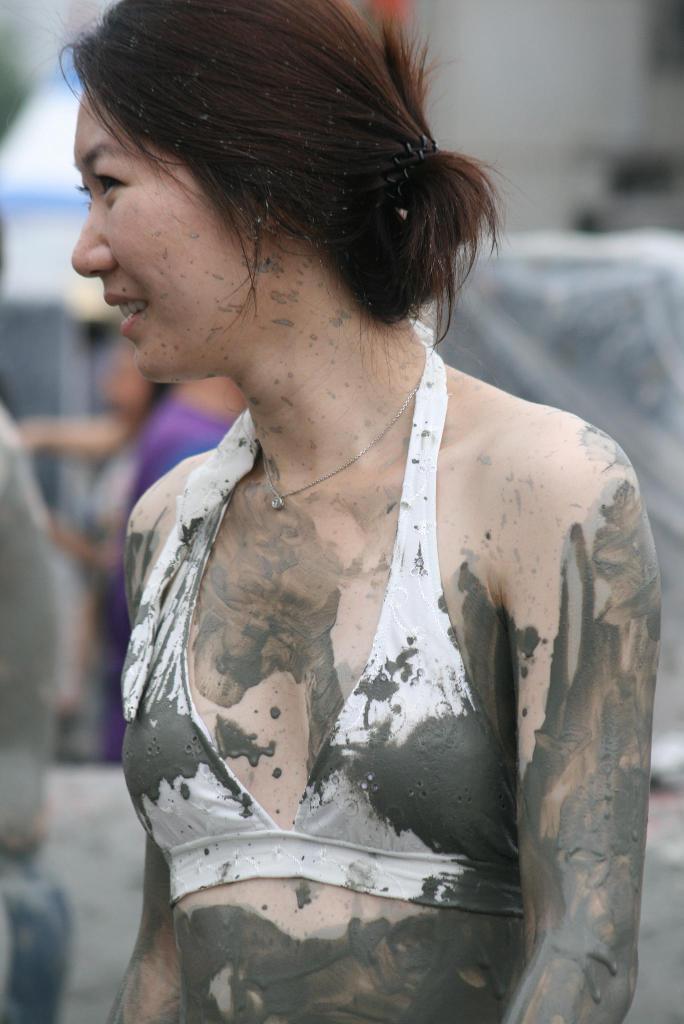How would you summarize this image in a sentence or two? In the image there is a woman in white bikini and mud all over her and behind the background the is blur. 